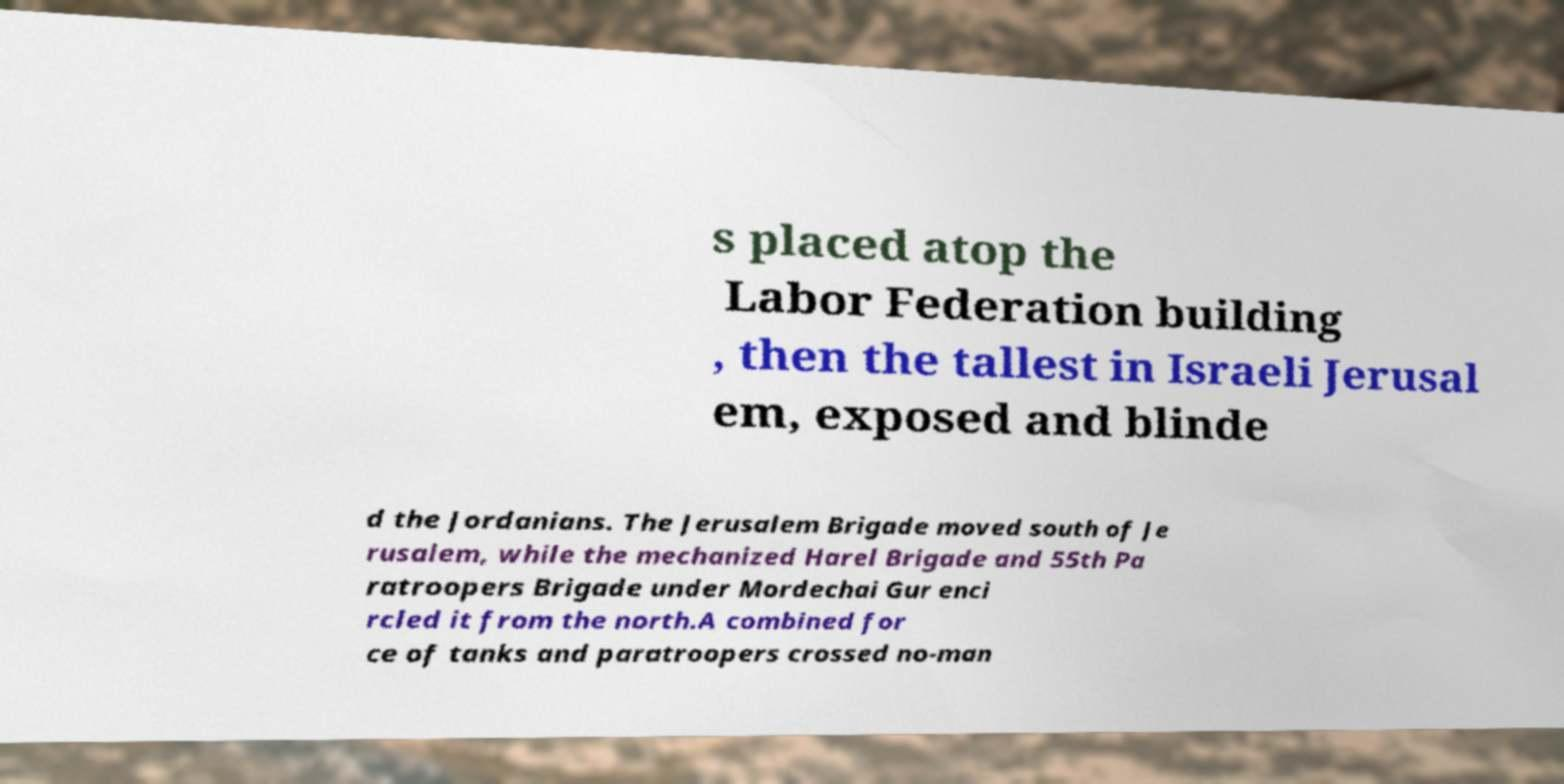Can you read and provide the text displayed in the image?This photo seems to have some interesting text. Can you extract and type it out for me? s placed atop the Labor Federation building , then the tallest in Israeli Jerusal em, exposed and blinde d the Jordanians. The Jerusalem Brigade moved south of Je rusalem, while the mechanized Harel Brigade and 55th Pa ratroopers Brigade under Mordechai Gur enci rcled it from the north.A combined for ce of tanks and paratroopers crossed no-man 